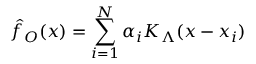Convert formula to latex. <formula><loc_0><loc_0><loc_500><loc_500>\hat { f } _ { O } ( x ) = \sum _ { i = 1 } ^ { N } \alpha _ { i } K _ { \Lambda } ( x - x _ { i } )</formula> 